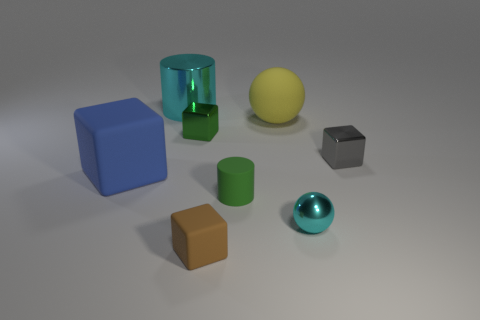Add 2 red matte cylinders. How many objects exist? 10 Subtract all cylinders. How many objects are left? 6 Subtract all small cyan shiny balls. Subtract all large purple rubber things. How many objects are left? 7 Add 2 tiny brown things. How many tiny brown things are left? 3 Add 3 gray cubes. How many gray cubes exist? 4 Subtract 1 gray cubes. How many objects are left? 7 